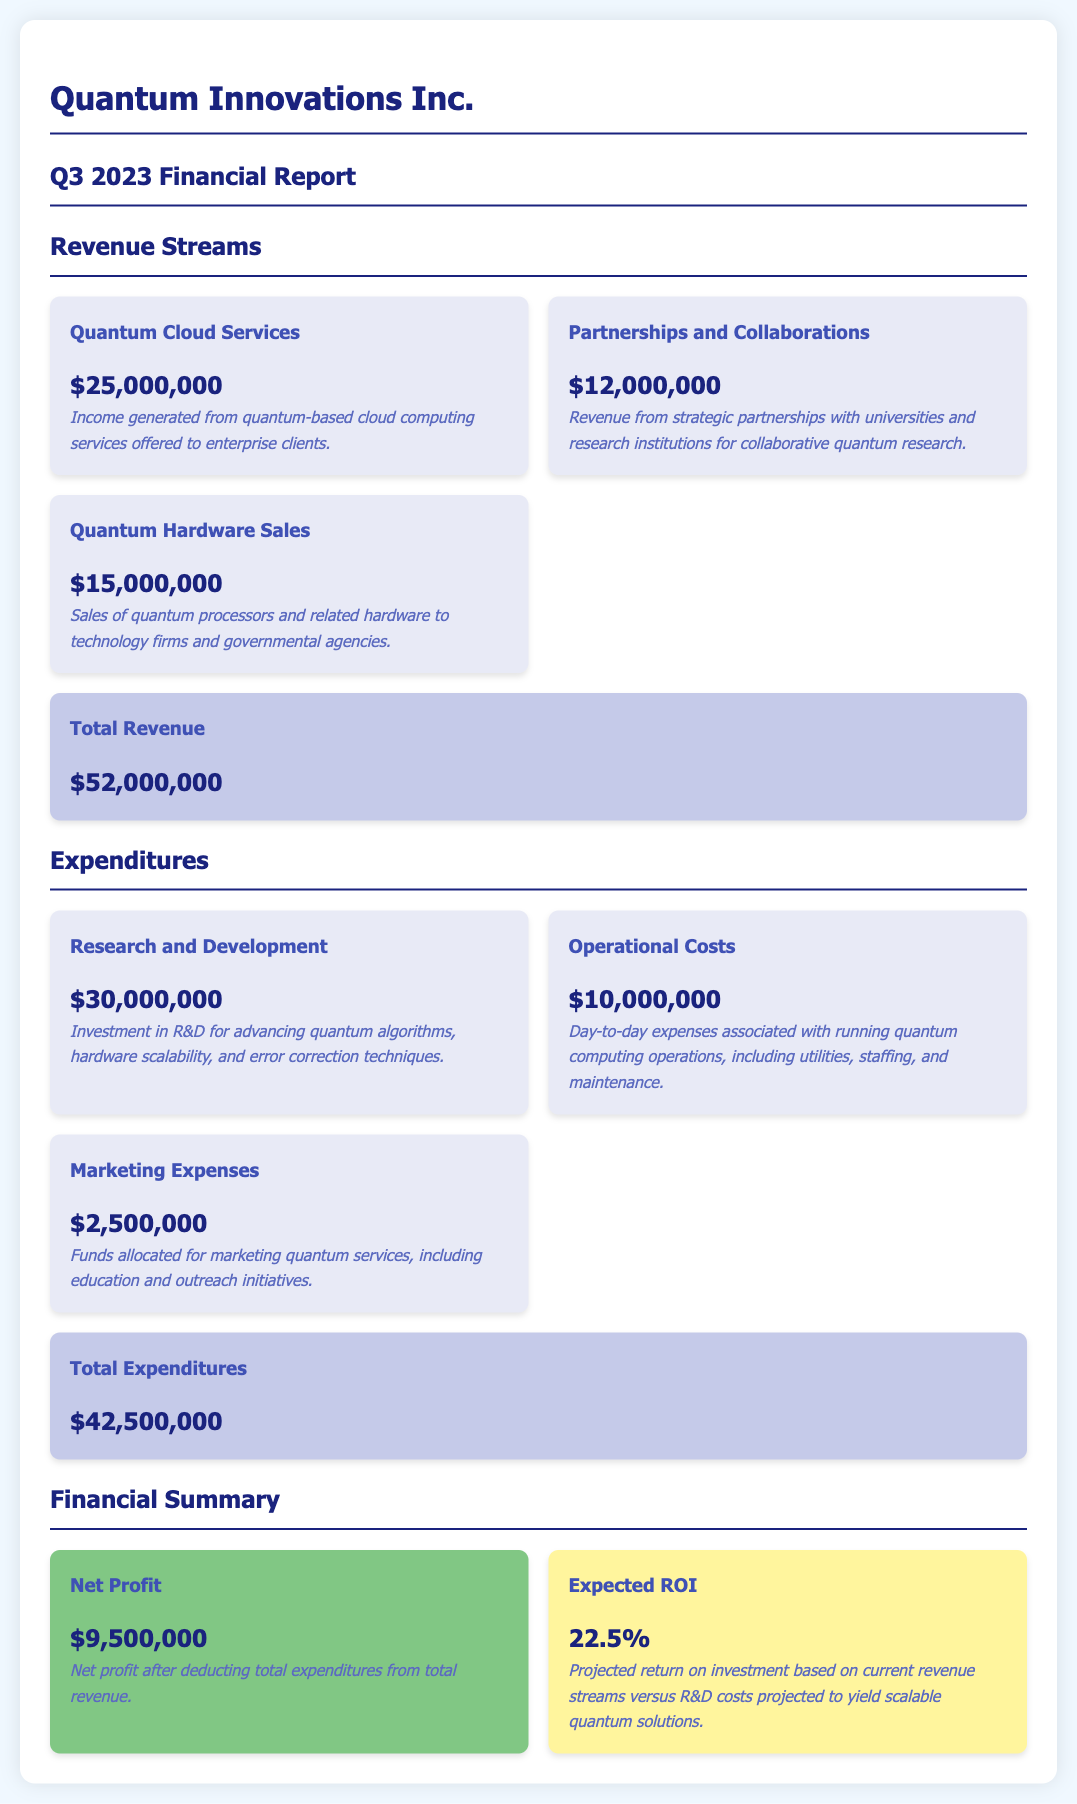What is the total revenue? The total revenue is the sum of all revenue sources in the document: $25,000,000 + $12,000,000 + $15,000,000 = $52,000,000.
Answer: $52,000,000 What are the R&D costs? R&D costs are specifically mentioned in the expenditures section as the amount spent on research and development, which is $30,000,000.
Answer: $30,000,000 What is the expected ROI? The expected ROI is directly stated in the financial summary section as a percentage based on current revenue streams versus R&D costs, which is 22.5%.
Answer: 22.5% What is the net profit? The net profit is provided in the financial summary, calculated as total revenue minus total expenditures, resulting in $9,500,000.
Answer: $9,500,000 What is the revenue from partnerships and collaborations? This revenue source is specified in the document and amounts to $12,000,000.
Answer: $12,000,000 What is included in operational costs? Operational costs cover day-to-day expenses associated with running quantum computing operations including utilities, staffing, and maintenance.
Answer: Utilities, staffing, and maintenance What is the total for marketing expenses? The total for marketing expenses is explicitly detailed in the expenditures section as $2,500,000.
Answer: $2,500,000 What type of cloud services generated revenue? Quantum cloud services, specifically mentioned in the revenue section, generated income from quantum-based cloud computing services.
Answer: Quantum-based cloud computing services How much revenue was generated from quantum hardware sales? The revenue from quantum hardware sales is stated in the document as $15,000,000.
Answer: $15,000,000 